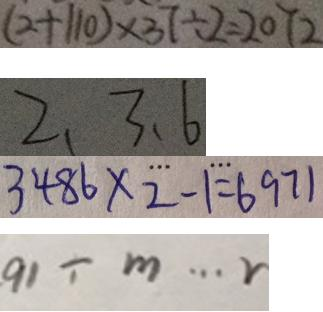Convert formula to latex. <formula><loc_0><loc_0><loc_500><loc_500>( 2 + 1 1 0 ) \times 3 7 \div 2 = 2 0 7 2 
 2 . 3 . 6 
 3 4 8 6 \times 2 - 1 = 6 9 7 1 
 9 1 \div m \cdots r</formula> 